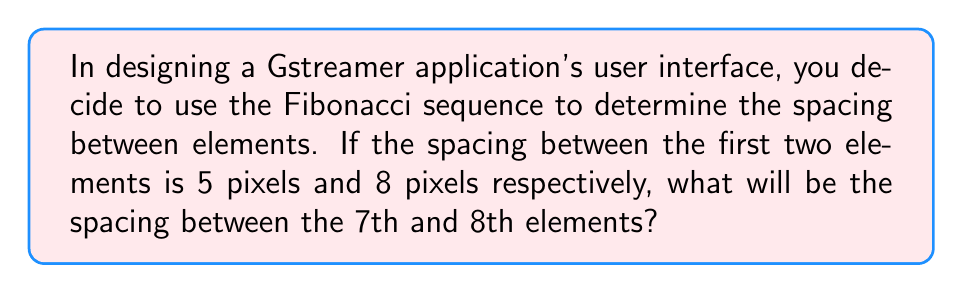Teach me how to tackle this problem. Let's approach this step-by-step:

1) First, recall that the Fibonacci sequence is defined as:
   $$F_n = F_{n-1} + F_{n-2}$$
   where $F_1 = 1$ and $F_2 = 1$

2) In this case, we're given that the first spacing is 5 pixels and the second is 8 pixels. This corresponds to the 5th and 6th terms of the standard Fibonacci sequence. Let's call our sequence $S_n$:

   $S_5 = 5$
   $S_6 = 8$

3) To find the spacing between the 7th and 8th elements, we need to calculate $S_7$ and $S_8$.

4) For $S_7$:
   $$S_7 = S_6 + S_5 = 8 + 5 = 13$$

5) For $S_8$:
   $$S_8 = S_7 + S_6 = 13 + 8 = 21$$

6) The spacing between the 7th and 8th elements is the difference between $S_8$ and $S_7$:
   $$S_8 - S_7 = 21 - 13 = 8$$

Therefore, the spacing between the 7th and 8th elements will be 8 pixels.
Answer: 8 pixels 